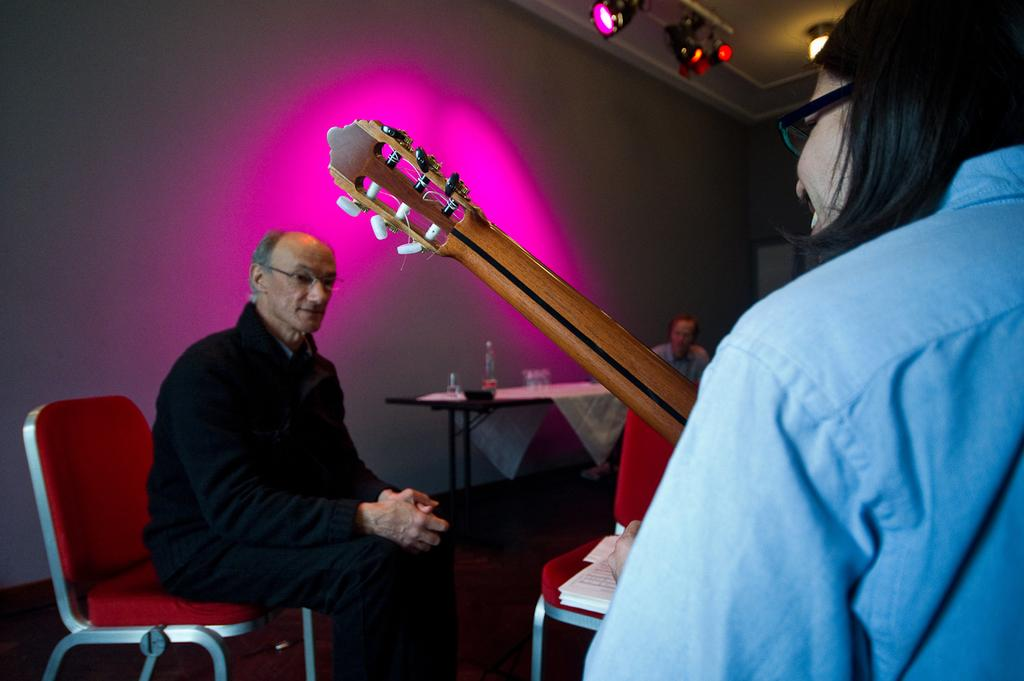What is the man in the image doing? The man is sitting on a chair in the image. What is in front of the man? There is a chair in front of the man. What is behind the man? There is a table behind the man. What can be seen on the table? There are objects on the table. What is visible in the background of the image? There is a wall visible in the image. What type of print can be seen on the wall in the image? There is no print visible on the wall in the image. How does the wax on the table interact with the objects in the image? There is no wax present on the table in the image. 